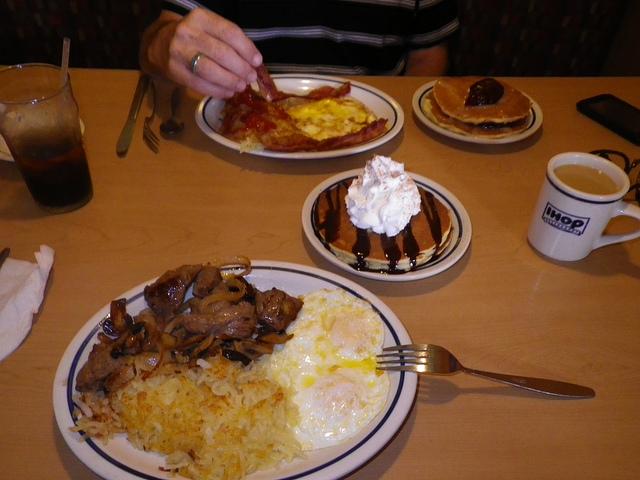What is the drink?
Keep it brief. Coffee. What is on the fingers of the person?
Write a very short answer. Ring. How many people are eating at the table?
Answer briefly. 2. Which meal of the day is this?
Write a very short answer. Breakfast. How many hands are in this picture?
Answer briefly. 1. Does this look like a healthy meal?
Write a very short answer. No. Are they eating pancakes?
Give a very brief answer. Yes. What is in the glass?
Write a very short answer. Coffee. Where is the cantaloupe?
Concise answer only. Nowhere. What is on the plate on the right?
Quick response, please. Pancakes. What is the wording on the coffee cup?
Write a very short answer. Ihop. What is the beverage of choice?
Be succinct. Coffee. 